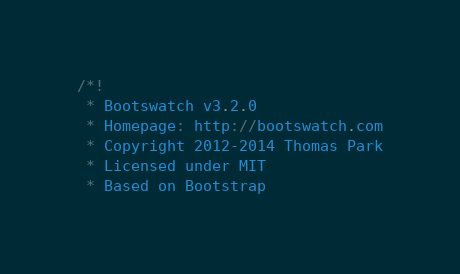Convert code to text. <code><loc_0><loc_0><loc_500><loc_500><_CSS_>/*!
 * Bootswatch v3.2.0
 * Homepage: http://bootswatch.com
 * Copyright 2012-2014 Thomas Park
 * Licensed under MIT
 * Based on Bootstrap</code> 